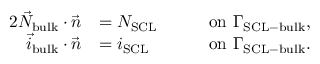Convert formula to latex. <formula><loc_0><loc_0><loc_500><loc_500>\begin{array} { r l r l } { { 2 } \vec { N } _ { b u l k } \cdot \vec { n } } & { = N _ { S C L } \quad } & & { o n \ \Gamma _ { S C L - b u l k } , } \\ { \vec { i } _ { b u l k } \cdot \vec { n } } & { = i _ { S C L } } & & { o n \ \Gamma _ { S C L - b u l k } . } \end{array}</formula> 